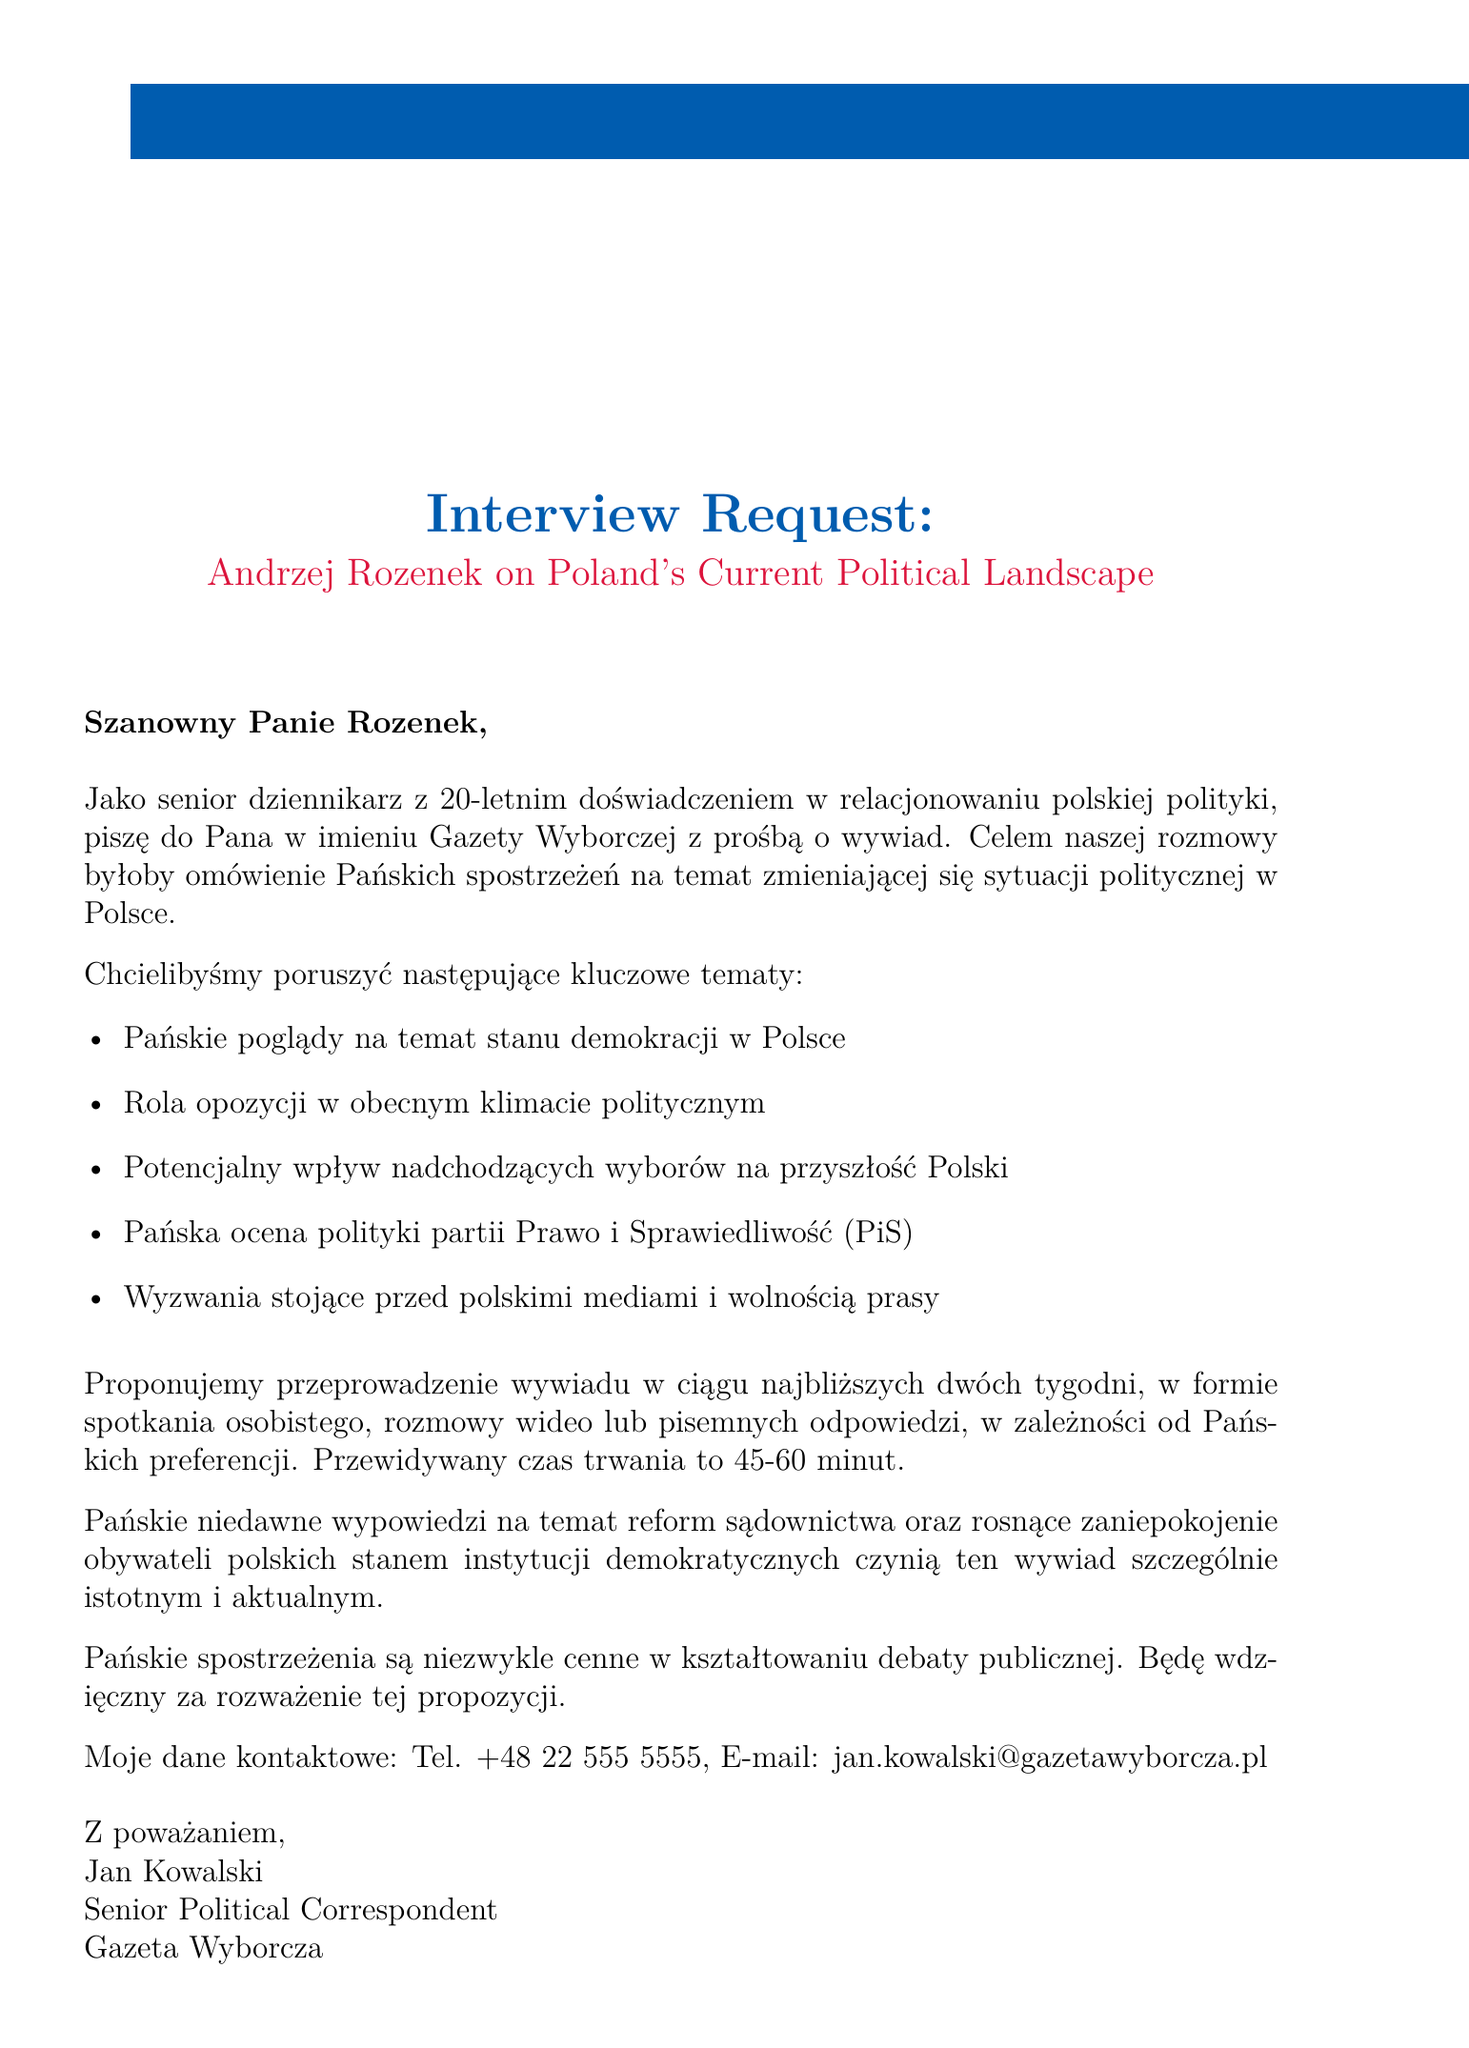What is the subject of the email? The subject line states the purpose of the email, highlighting the request for an interview and the topic of discussion.
Answer: Interview Request: Andrzej Rozenek on Poland's Current Political Landscape Who is the sender of the email? The document includes the signature of the sender, indicating their name and title.
Answer: Jan Kowalski How many years of experience does the journalist have? The document mentions the journalist's experience level directly.
Answer: 20 years What are the proposed formats for the interview? The email lists different formats that are acceptable for the interview.
Answer: In-person, Video call, Written responses What is the desired duration of the interview? The document specifies the expected length of the interview, giving a time range.
Answer: 45-60 minutes What is a key topic mentioned in the email regarding Polish politics? The email lists several key topics that the interview would cover, showcasing the areas of discussion.
Answer: The role of the opposition in the current political climate What timeframe is suggested for scheduling the interview? The email specifies when the sender would like to conduct the interview.
Answer: Within the next two weeks What publication is the journalist affiliated with? The document mentions the name of the publication where the journalist works.
Answer: Gazeta Wyborcza What is indicated as a recent event that makes the interview significant? The email highlights a recent topic of discussion that adds urgency to the interview request.
Answer: Your recent statements on judicial reforms 